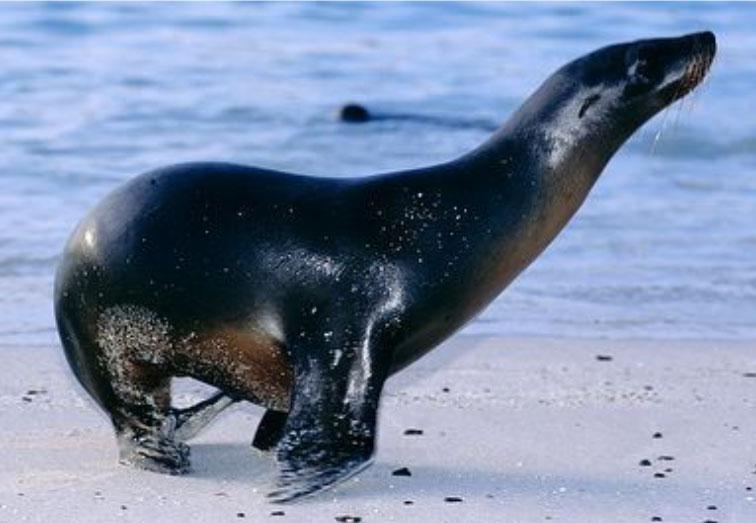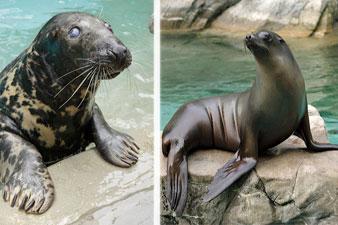The first image is the image on the left, the second image is the image on the right. Considering the images on both sides, is "The right image has a plain white background." valid? Answer yes or no. No. The first image is the image on the left, the second image is the image on the right. Given the left and right images, does the statement "There are only two seals and both are looking in different directions." hold true? Answer yes or no. No. 